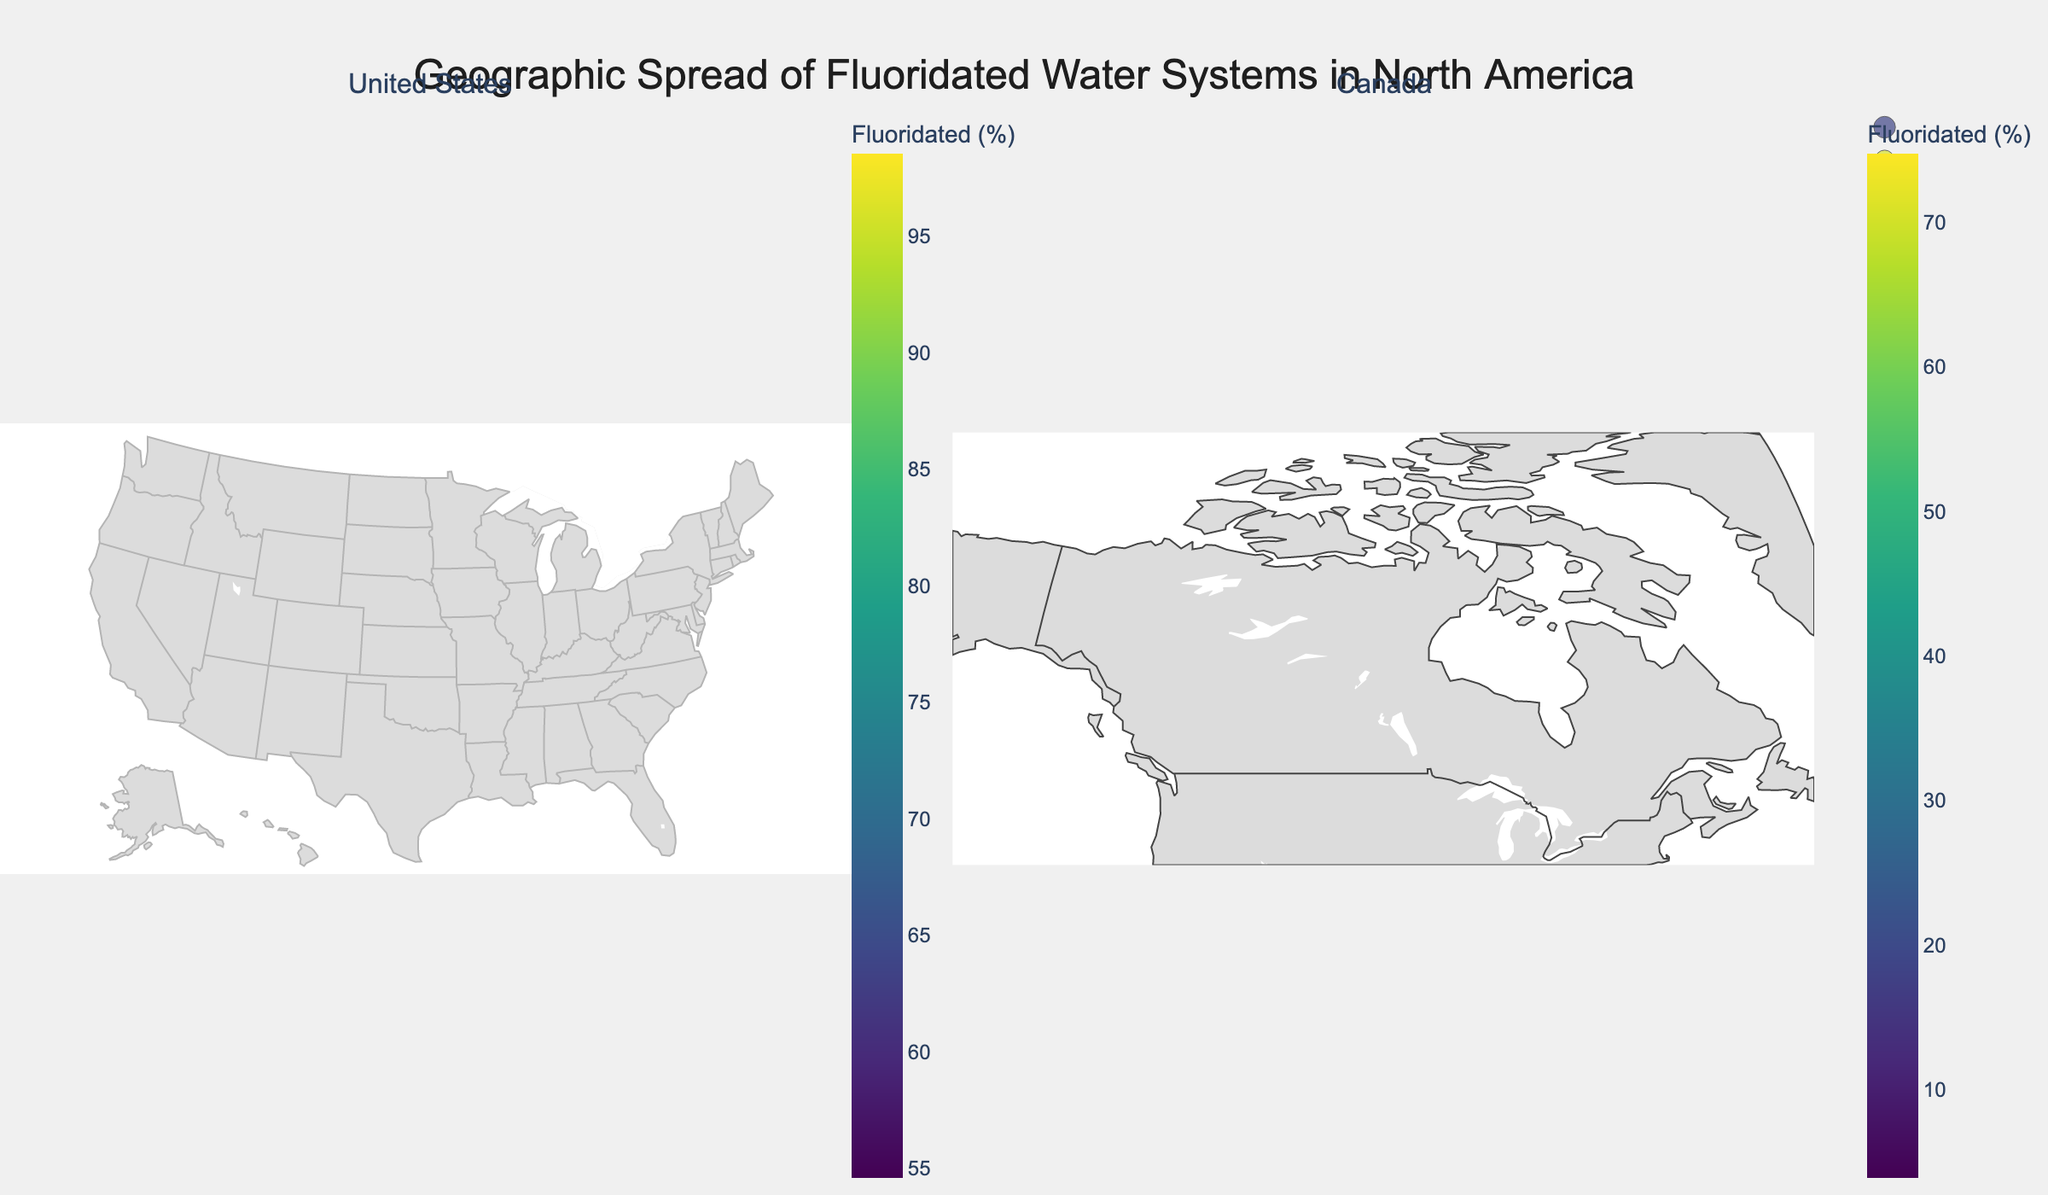What's the percentage of the population with fluoridated water in Illinois? The location on the geographic plot indicates Illinois with a 98.5% fluoridation rate.
Answer: 98.5% How many states in the US have a fluoridation rate greater than 90%? By analyzing the plot for the US, the states with a fluoridation rate above 90% are Illinois (98.5%), Ohio (92.2%), Michigan (90.2%), and Georgia (96.3%). This sums to 4 states.
Answer: 4 Which Canadian province has the lowest percentage of fluoridated water, and what is that percentage? By examining the Canadian sub-plot, the lowest fluoridation percentage is in British Columbia with 3.9%.
Answer: British Columbia, 3.9% What's the total population served by fluoridated water systems in Texas and Florida combined? The populations in Texas (22,000,000) and Florida (15,600,000) add up to 37,600,000.
Answer: 37,600,000 What is the difference in the percentage of fluoridated water between New York and Pennsylvania? The percentage in New York is 71.1%, and in Pennsylvania, it is 54.6%. The difference is 71.1% - 54.6% = 16.5%.
Answer: 16.5% Which region in North America (considering both US states and Canadian provinces) has the highest fluoridation rate, and what is the rate? By reviewing both subplots, Illinois has the highest fluoridation rate at 98.5%.
Answer: Illinois, 98.5% Compare the population served by fluoridated water in Ontario and North Carolina. Which region serves a larger population? Ontario serves 9.5 million, while North Carolina serves 8.7 million. Therefore, Ontario serves a larger population.
Answer: Ontario If you average the percentage fluoridation for all the Canadian provinces listed, what value do you get? The sum of percentages for Ontario (70.9), Quebec (6.4), British Columbia (3.9), Alberta (74.7), Manitoba (69.1) is 224.0. Dividing by 5 gives an average of 44.8%.
Answer: 44.8% How many regions (either US states or Canadian provinces) have a population served by fluoridated water less than 1 million? Quebec (500,000) and British Columbia (180,000) are the regions with populations served under 1 million, summing to 2 regions.
Answer: 2 